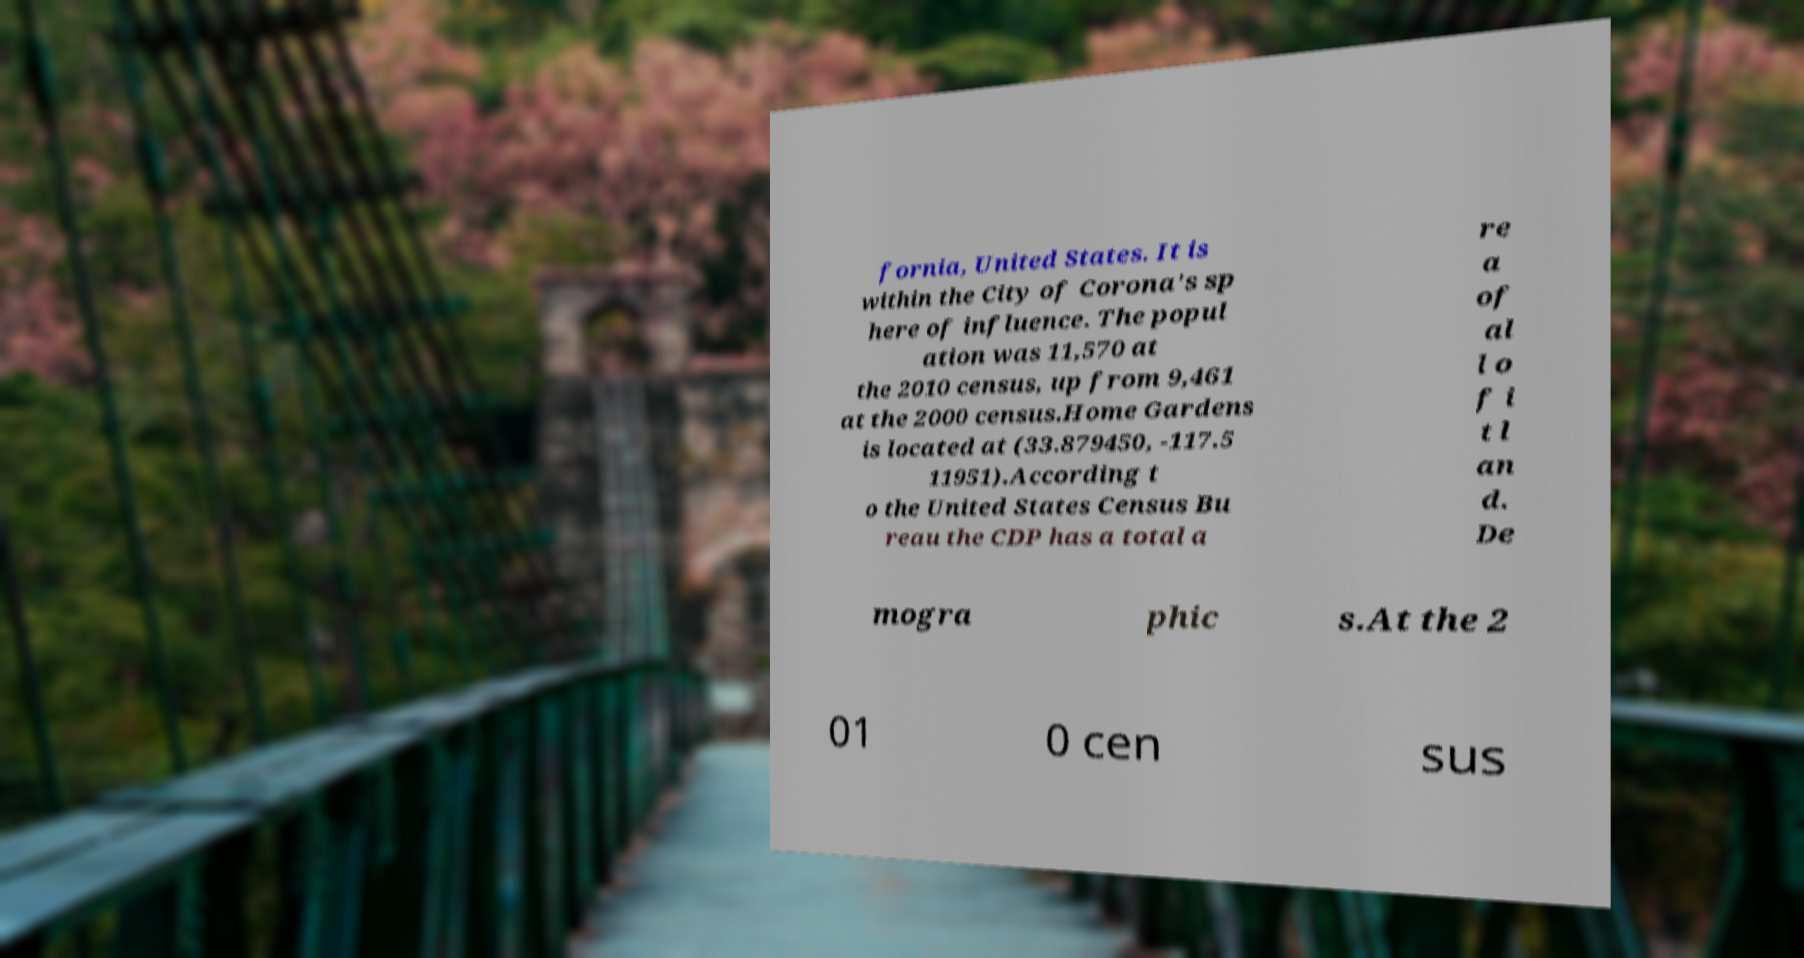Can you accurately transcribe the text from the provided image for me? fornia, United States. It is within the City of Corona's sp here of influence. The popul ation was 11,570 at the 2010 census, up from 9,461 at the 2000 census.Home Gardens is located at (33.879450, -117.5 11951).According t o the United States Census Bu reau the CDP has a total a re a of al l o f i t l an d. De mogra phic s.At the 2 01 0 cen sus 